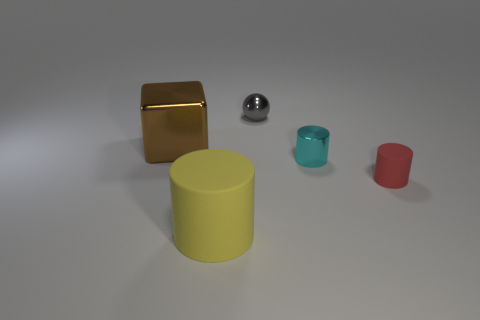How big is the matte object on the right side of the tiny metal thing that is left of the shiny object that is in front of the large brown metallic object?
Offer a terse response. Small. Is the material of the tiny cyan cylinder the same as the big thing that is in front of the tiny rubber cylinder?
Keep it short and to the point. No. Is the shape of the big brown metallic object the same as the big yellow rubber thing?
Provide a succinct answer. No. What number of other things are made of the same material as the big block?
Offer a very short reply. 2. What number of blue objects are the same shape as the large yellow object?
Keep it short and to the point. 0. The metallic thing that is to the right of the big brown thing and behind the cyan cylinder is what color?
Give a very brief answer. Gray. How many big blue matte cylinders are there?
Keep it short and to the point. 0. Does the yellow rubber thing have the same size as the brown metallic block?
Ensure brevity in your answer.  Yes. Are there any other shiny balls that have the same color as the tiny metal sphere?
Ensure brevity in your answer.  No. There is a tiny metal thing that is in front of the tiny gray sphere; does it have the same shape as the yellow object?
Your answer should be compact. Yes. 